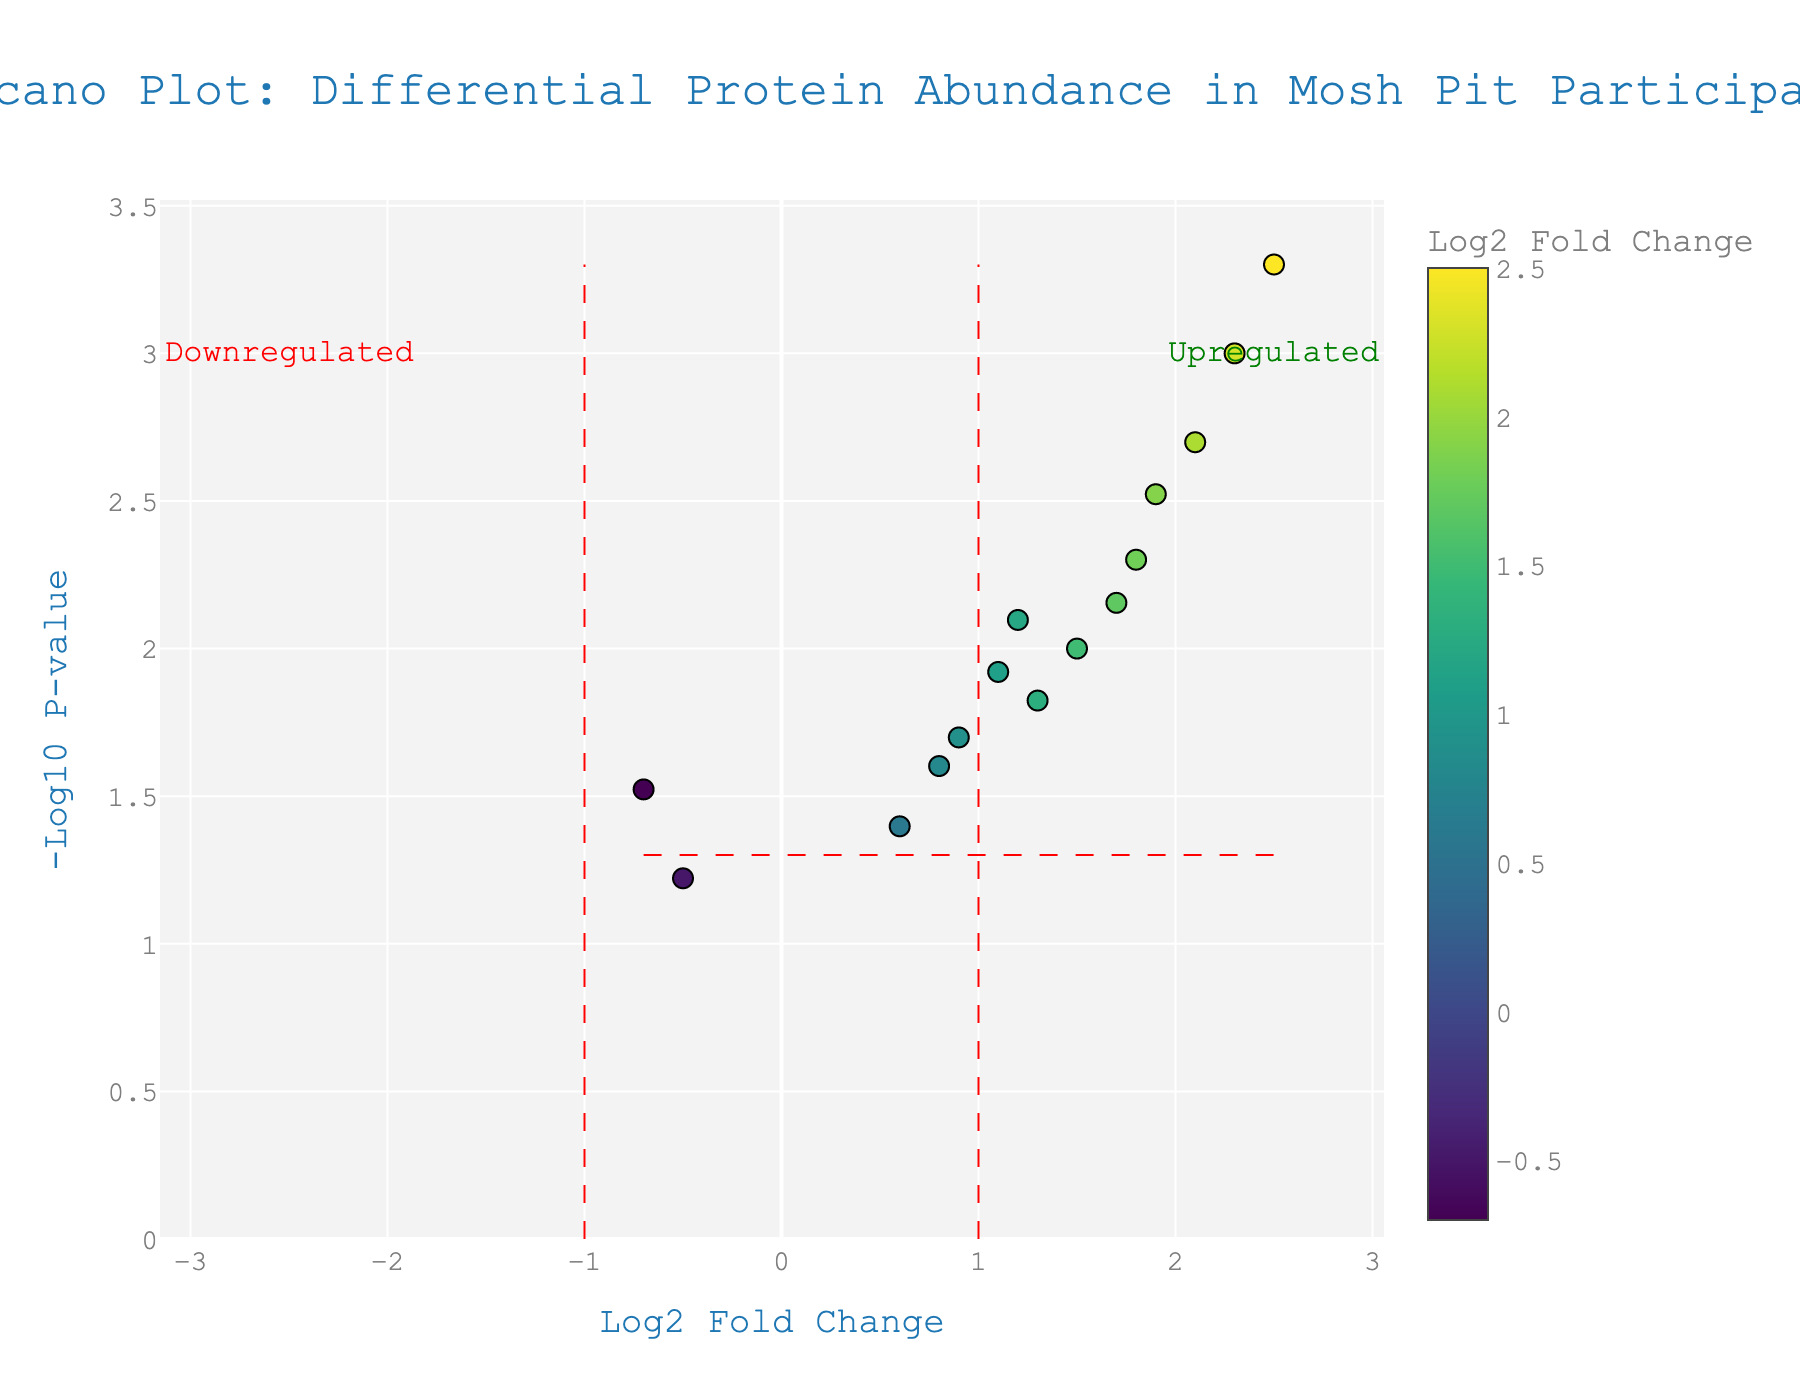What is the title of the figure? The title is located at the top of the figure and summarizes the contents of the plot. The text is "Volcano Plot: Differential Protein Abundance in Mosh Pit Participants".
Answer: Volcano Plot: Differential Protein Abundance in Mosh Pit Participants What are the labels of the x-axis and y-axis? The x-axis and y-axis labels are present to provide context for the plot's axes. The x-axis is labeled "Log2 Fold Change" and the y-axis is labeled "-Log10 P-value".
Answer: Log2 Fold Change, -Log10 P-value Which protein has the highest log2 fold change? Look at the x-axis and identify the rightmost point which represents the highest log2 fold change. Hover text shows the protein with the highest value is "Adrenaline" with a log2 fold change of 2.5.
Answer: Adrenaline Which protein has the smallest p-value? Look at the y-axis and identify the highest point which represents the smallest p-value (largest -log10 p-value). Hover text shows the protein is "Adrenaline" with a p-value of 0.0005.
Answer: Adrenaline How many proteins are significantly upregulated? To determine significant upregulation, look for points with a log2 fold change greater than 1 and a p-value less than 0.05 (points above the y-axis red line with x values greater than the right red line). Count the eligible proteins: Myoglobin, Creatine kinase, C-reactive protein, Adrenaline, Interleukin-6, Troponin I, Cortisol.
Answer: 7 How many proteins have a negative log2 fold change? Observe the points to the left of the central axis at x = 0. These represent proteins with negative log2 fold changes. The proteins are Albumin and Glutathione peroxidase.
Answer: 2 Which proteins are annotated as upregulated and downregulated? The plot annotates the regions to the right of the fold change threshold lines as "Upregulated" (positive log2 fold change) and left of the threshold lines as "Downregulated" (negative log2 fold change).
Answer: Upregulated, Downregulated Which proteins have a log2 fold change greater than 1.5 and a p-value less than 0.01? Review the points that meet both criteria: right of x = 1.5 and above y = 2. Glance these proteins and verify through hover text. They are Myoglobin, C-reactive protein, Adrenaline, and Interleukin-6.
Answer: Myoglobin, C-reactive protein, Adrenaline, Interleukin-6 What is the range of p-values shown in the figure? The range is determined by examining the maximum and minimum values on the y-axis, which corresponds to the largest and smallest -log10(p-value). The maximum -log10(p-value) is ~3 (Adrenaline), indicating a p-value of 0.0005, and the minimum -log10(p-value) visible is around 1 (Glutathione peroxidase), indicating a p-value of ~0.1.
Answer: 0.0005 to 0.06 